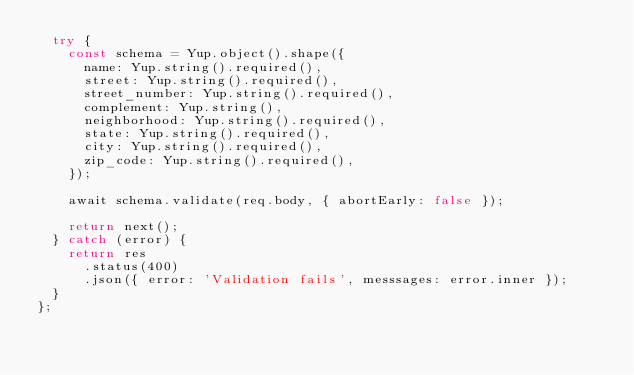<code> <loc_0><loc_0><loc_500><loc_500><_JavaScript_>  try {
    const schema = Yup.object().shape({
      name: Yup.string().required(),
      street: Yup.string().required(),
      street_number: Yup.string().required(),
      complement: Yup.string(),
      neighborhood: Yup.string().required(),
      state: Yup.string().required(),
      city: Yup.string().required(),
      zip_code: Yup.string().required(),
    });

    await schema.validate(req.body, { abortEarly: false });

    return next();
  } catch (error) {
    return res
      .status(400)
      .json({ error: 'Validation fails', messsages: error.inner });
  }
};
</code> 